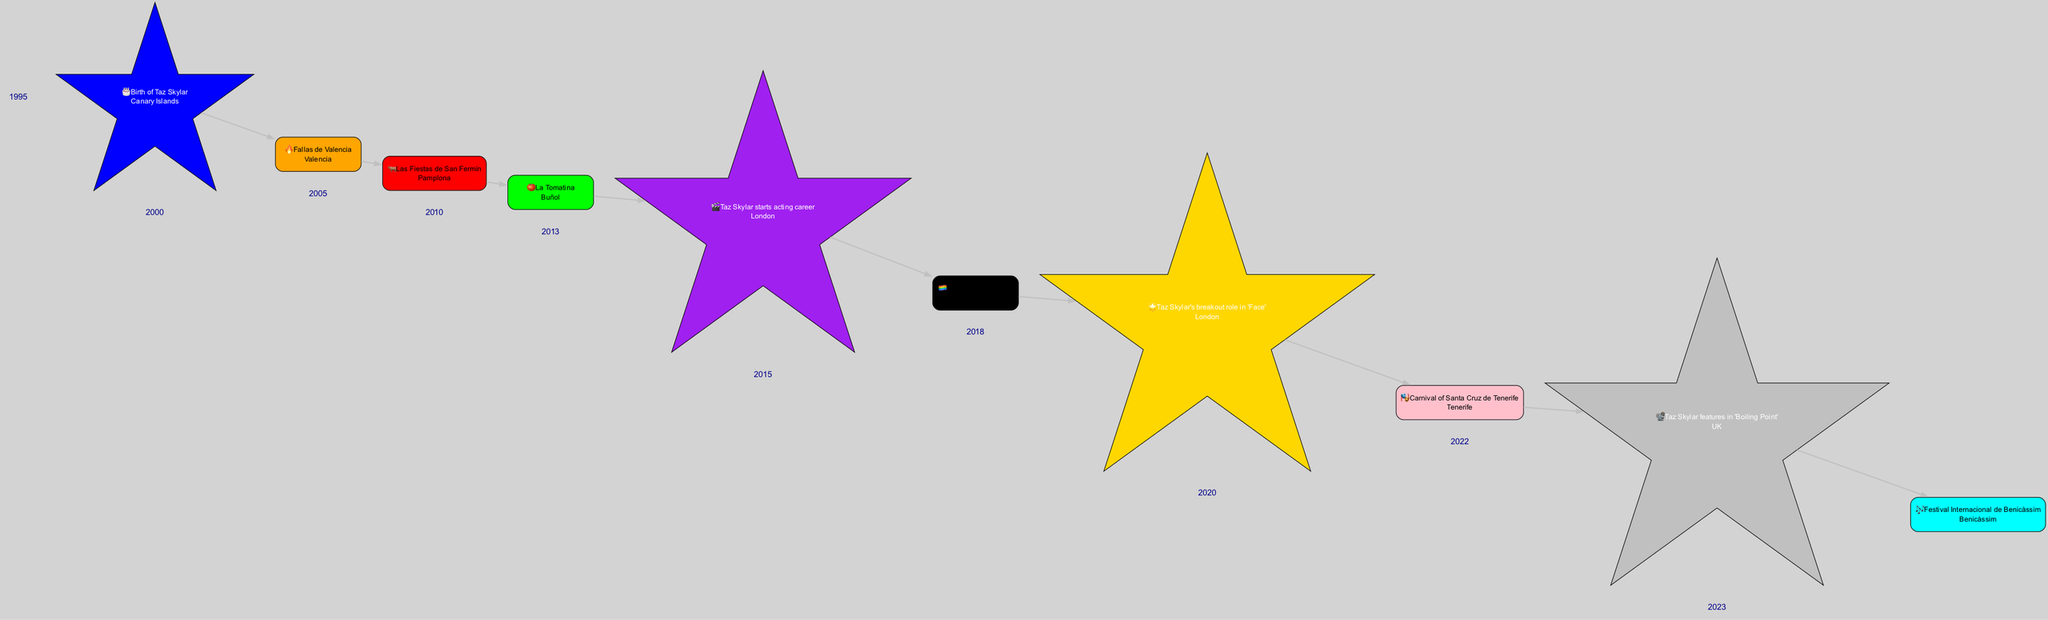What year was Taz Skylar born? The diagram indicates that Taz Skylar was born in 1995, as this event is represented as the first entry on the timeline.
Answer: 1995 How many cultural events are represented prior to Taz Skylar's first acting career event? By counting the entries before 2013 on the timeline, we see there are 5 cultural events listed before Taz Skylar starts his acting career.
Answer: 5 What location is associated with the Madrid Pride Parade? The timeline specifies that the Madrid Pride Parade, one of the cultural events, takes place in Madrid, as indicated next to the event.
Answer: Madrid In which year did Taz Skylar have his breakout role in 'Face'? According to the diagram, Taz Skylar's breakout role in 'Face' is indicated as an event in 2018, which is the year mentioned next to that event.
Answer: 2018 What icon represents the event of La Tomatina? The event of La Tomatina is represented by the tomato icon, which is displayed next to the event label on the diagram.
Answer: 🍅 Which event occurs after Taz Skylar features in 'Boiling Point'? The diagram illustrates that the Festival Internacional de Benicàssim is the event that occurs after Taz Skylar features in 'Boiling Point', based on the chronological order shown.
Answer: Festival Internacional de Benicàssim How many events are connected to Taz Skylar's career highlights throughout the timeline? By reviewing the diagram, we can see that there are 4 nodes directly connected to Taz Skylar's career highlights, including his birth and three significant events in his acting career.
Answer: 4 Which cultural event is associated with an orange color? The diagram shows that the Fallas de Valencia is associated with an orange color, as noted next to the event in the timeline.
Answer: Fallas de Valencia What color is used to represent the Carnival of Santa Cruz de Tenerife? The timeline indicates that the Carnival of Santa Cruz de Tenerife is represented with pink color, as shown in the event details.
Answer: Pink 